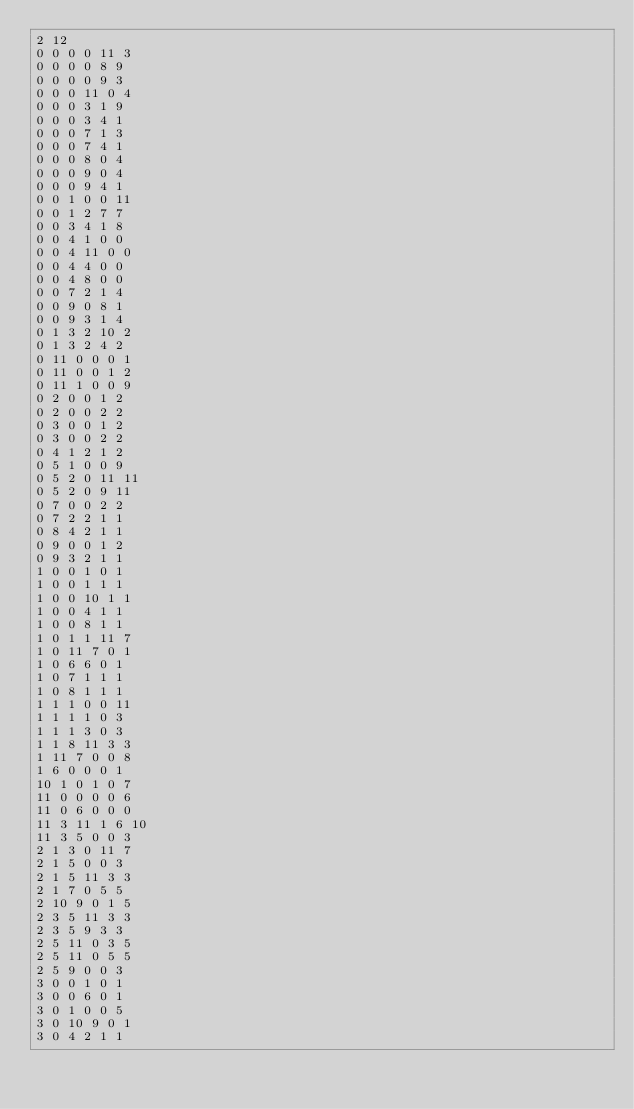<code> <loc_0><loc_0><loc_500><loc_500><_SQL_>2 12
0 0 0 0 11 3
0 0 0 0 8 9
0 0 0 0 9 3
0 0 0 11 0 4
0 0 0 3 1 9
0 0 0 3 4 1
0 0 0 7 1 3
0 0 0 7 4 1
0 0 0 8 0 4
0 0 0 9 0 4
0 0 0 9 4 1
0 0 1 0 0 11
0 0 1 2 7 7
0 0 3 4 1 8
0 0 4 1 0 0
0 0 4 11 0 0
0 0 4 4 0 0
0 0 4 8 0 0
0 0 7 2 1 4
0 0 9 0 8 1
0 0 9 3 1 4
0 1 3 2 10 2
0 1 3 2 4 2
0 11 0 0 0 1
0 11 0 0 1 2
0 11 1 0 0 9
0 2 0 0 1 2
0 2 0 0 2 2
0 3 0 0 1 2
0 3 0 0 2 2
0 4 1 2 1 2
0 5 1 0 0 9
0 5 2 0 11 11
0 5 2 0 9 11
0 7 0 0 2 2
0 7 2 2 1 1
0 8 4 2 1 1
0 9 0 0 1 2
0 9 3 2 1 1
1 0 0 1 0 1
1 0 0 1 1 1
1 0 0 10 1 1
1 0 0 4 1 1
1 0 0 8 1 1
1 0 1 1 11 7
1 0 11 7 0 1
1 0 6 6 0 1
1 0 7 1 1 1
1 0 8 1 1 1
1 1 1 0 0 11
1 1 1 1 0 3
1 1 1 3 0 3
1 1 8 11 3 3
1 11 7 0 0 8
1 6 0 0 0 1
10 1 0 1 0 7
11 0 0 0 0 6
11 0 6 0 0 0
11 3 11 1 6 10
11 3 5 0 0 3
2 1 3 0 11 7
2 1 5 0 0 3
2 1 5 11 3 3
2 1 7 0 5 5
2 10 9 0 1 5
2 3 5 11 3 3
2 3 5 9 3 3
2 5 11 0 3 5
2 5 11 0 5 5
2 5 9 0 0 3
3 0 0 1 0 1
3 0 0 6 0 1
3 0 1 0 0 5
3 0 10 9 0 1
3 0 4 2 1 1</code> 